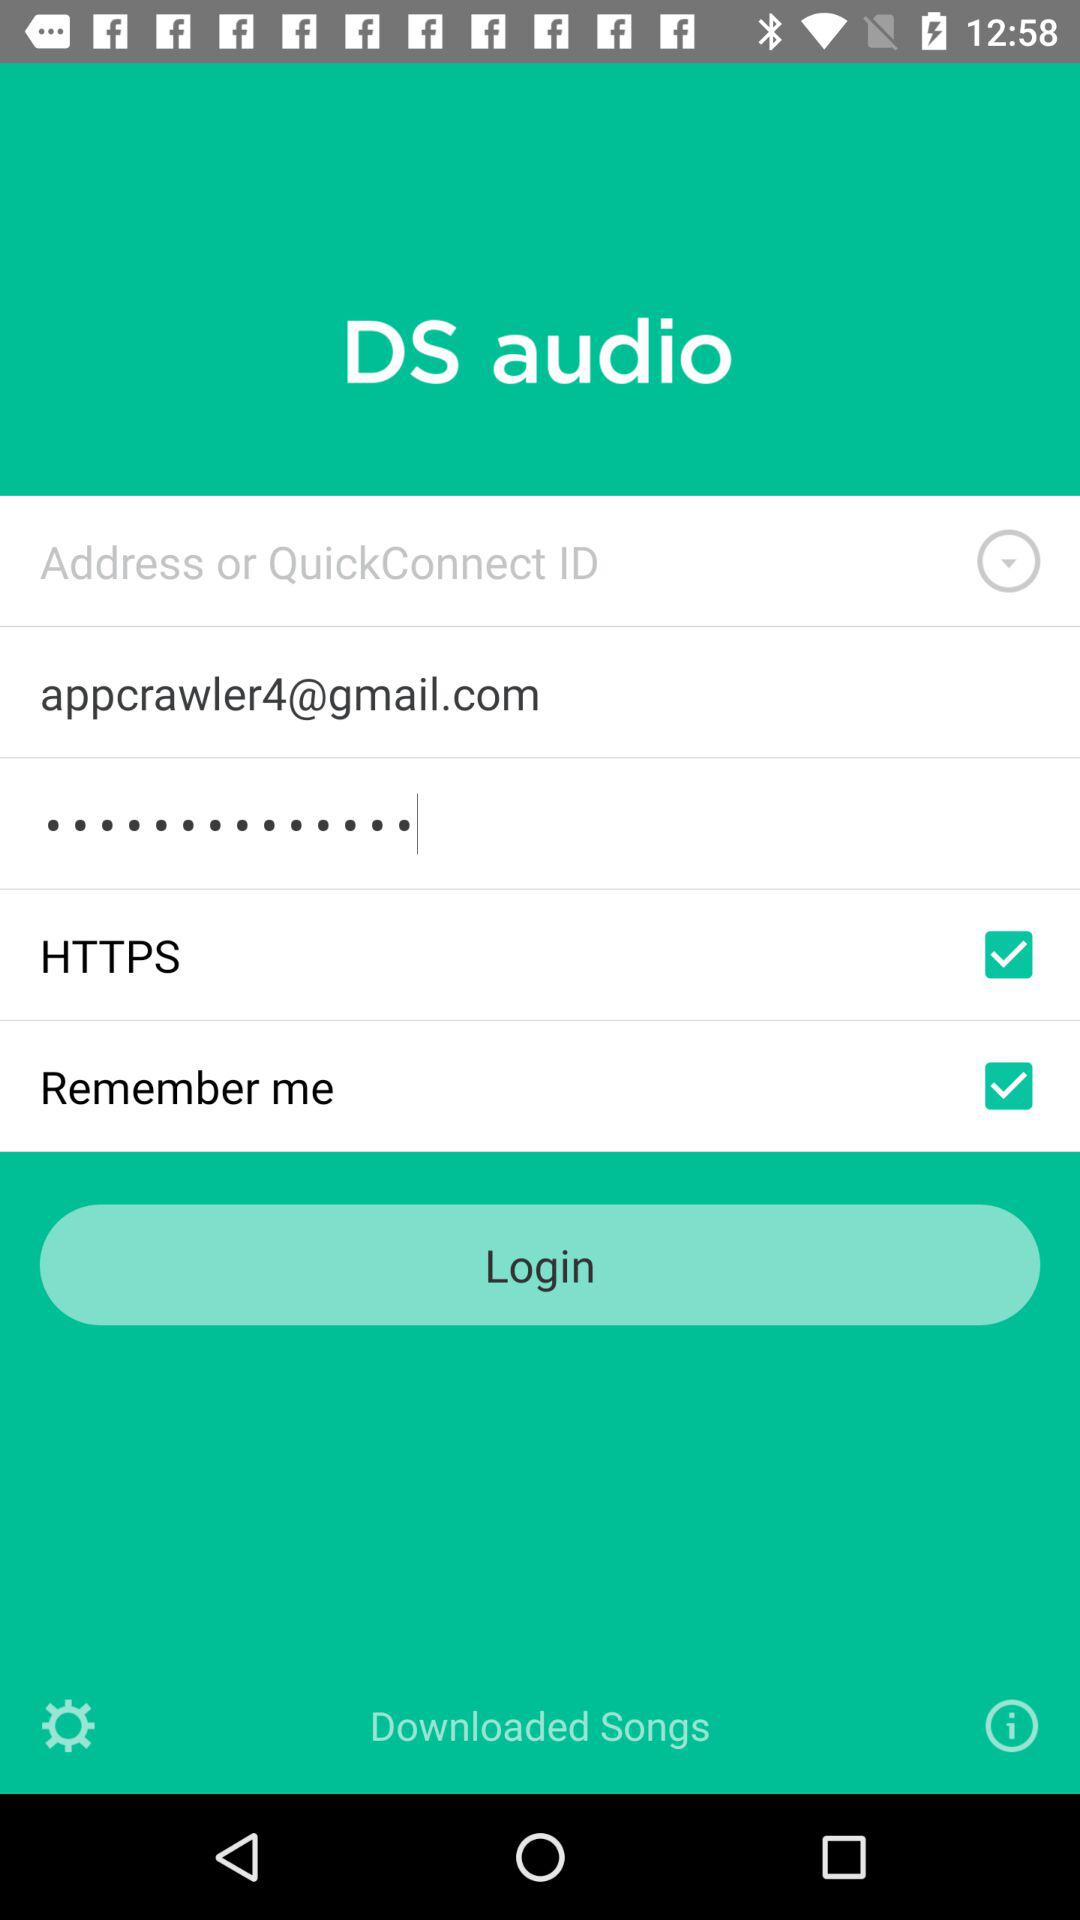What is the application name? The application name is "DS audio". 